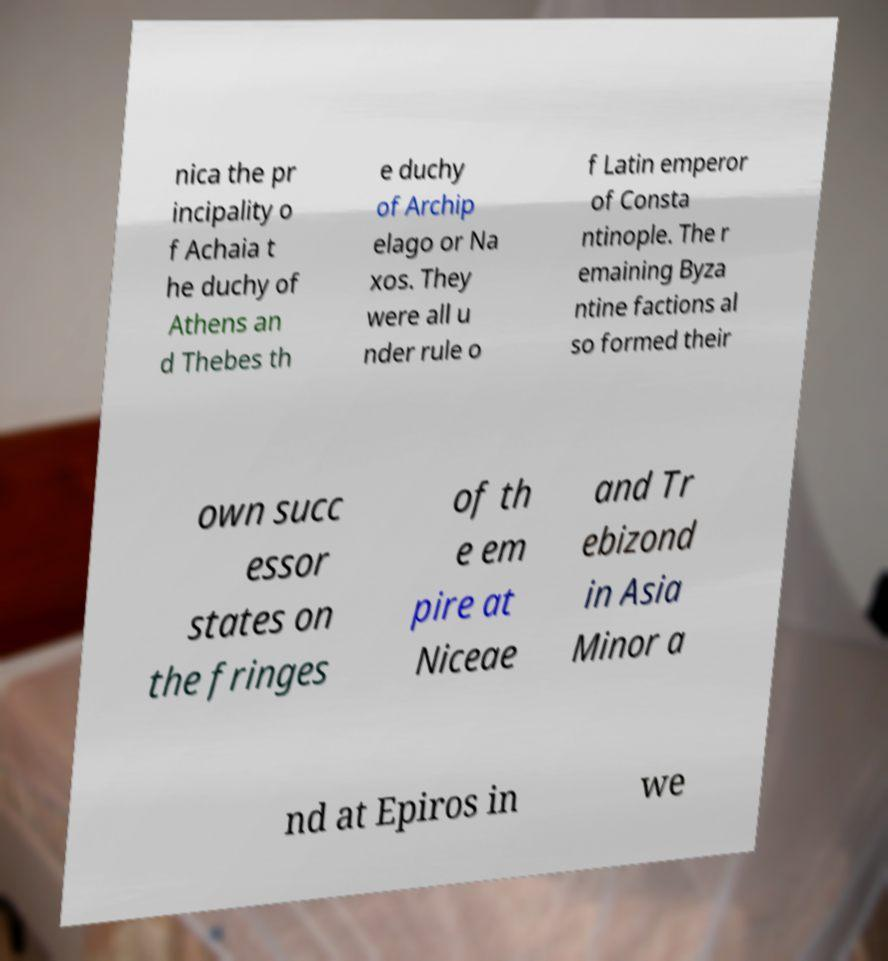Can you read and provide the text displayed in the image?This photo seems to have some interesting text. Can you extract and type it out for me? nica the pr incipality o f Achaia t he duchy of Athens an d Thebes th e duchy of Archip elago or Na xos. They were all u nder rule o f Latin emperor of Consta ntinople. The r emaining Byza ntine factions al so formed their own succ essor states on the fringes of th e em pire at Niceae and Tr ebizond in Asia Minor a nd at Epiros in we 